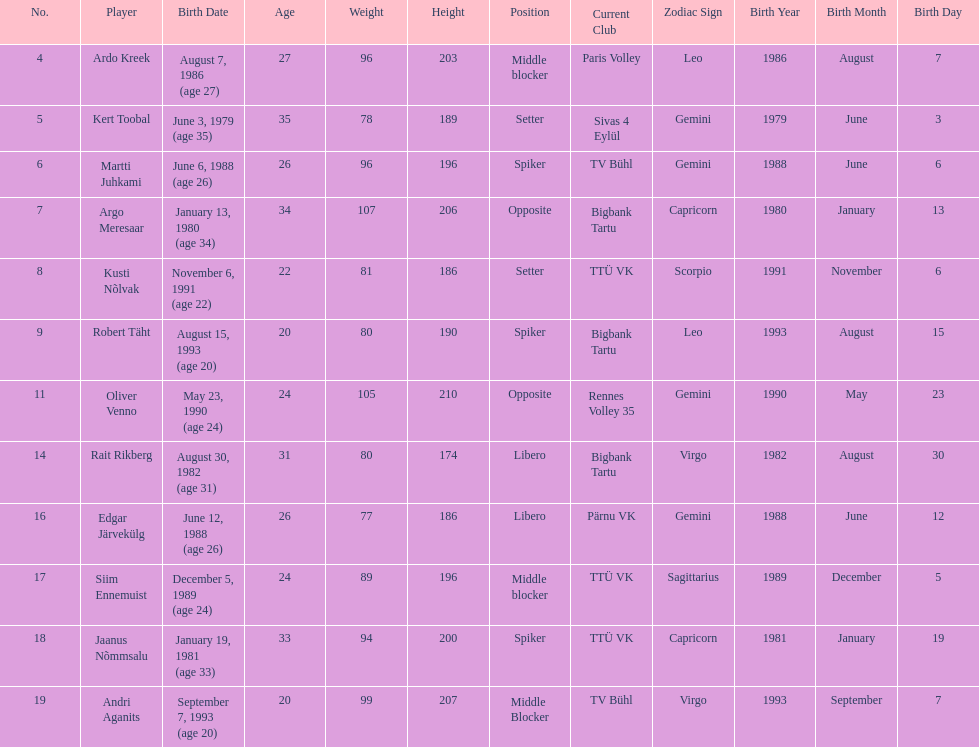Who holds the title of the tallest player on estonia's men's national volleyball team? Oliver Venno. 